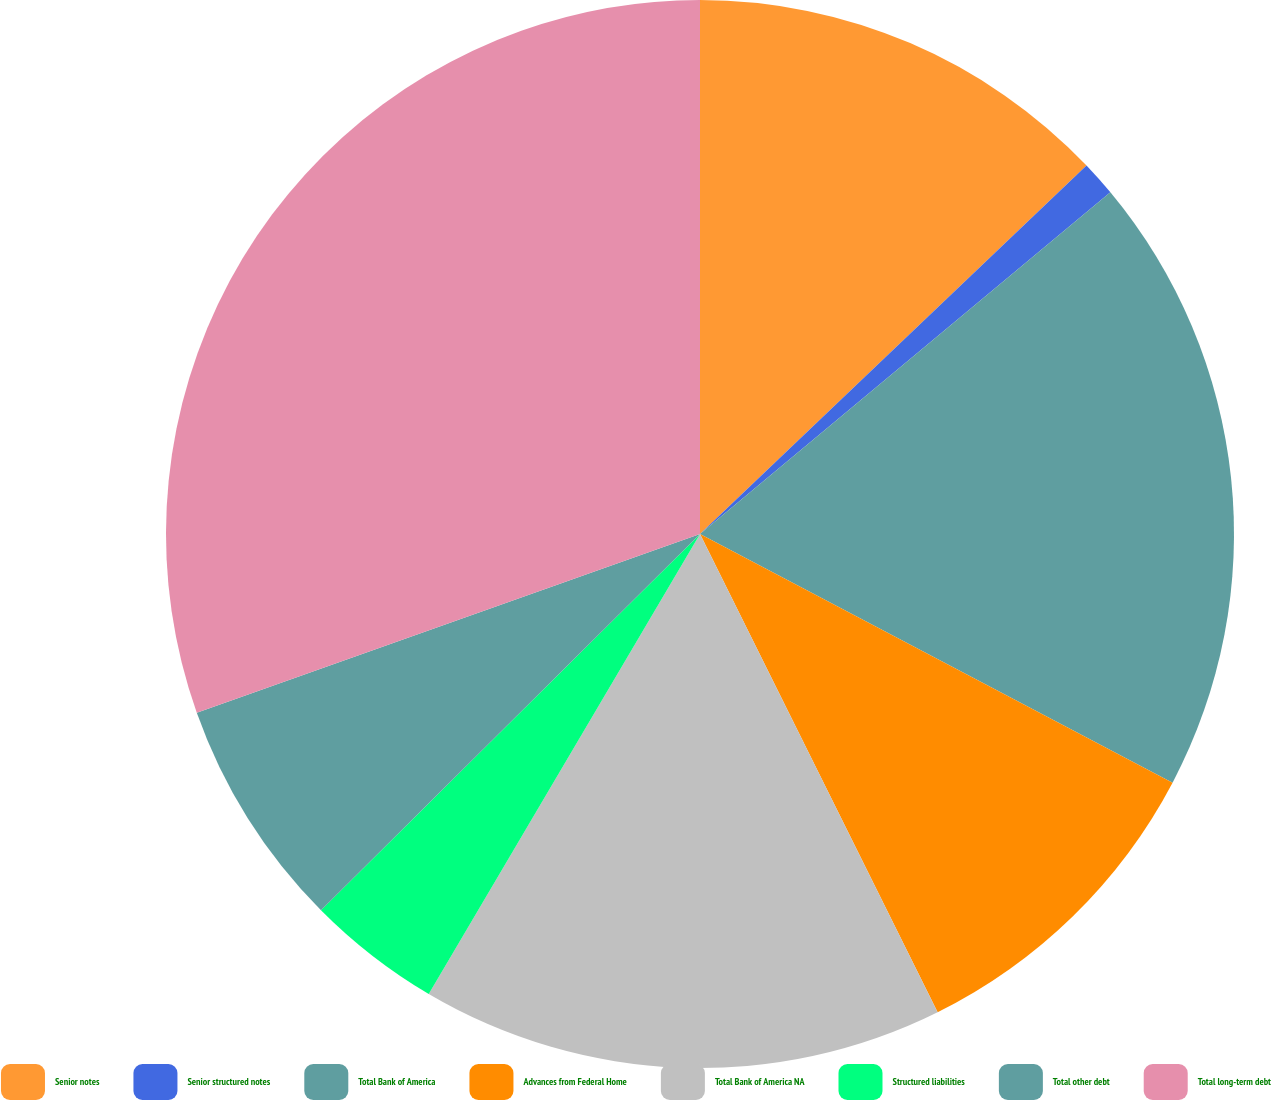<chart> <loc_0><loc_0><loc_500><loc_500><pie_chart><fcel>Senior notes<fcel>Senior structured notes<fcel>Total Bank of America<fcel>Advances from Federal Home<fcel>Total Bank of America NA<fcel>Structured liabilities<fcel>Total other debt<fcel>Total long-term debt<nl><fcel>12.88%<fcel>1.07%<fcel>18.76%<fcel>9.95%<fcel>15.82%<fcel>4.08%<fcel>7.01%<fcel>30.43%<nl></chart> 